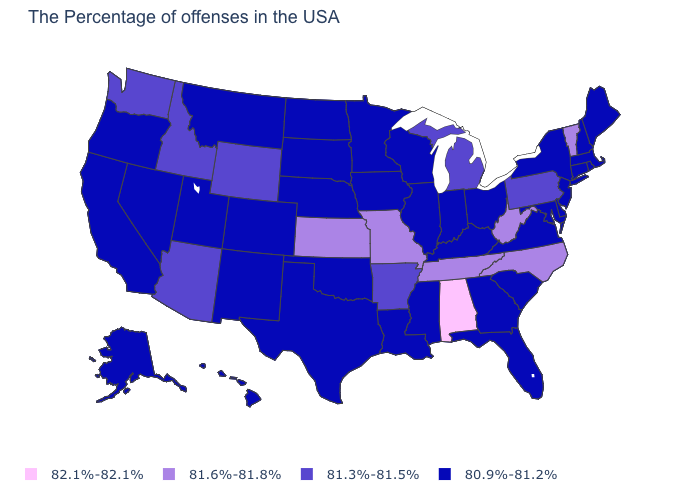What is the value of Utah?
Give a very brief answer. 80.9%-81.2%. Does New Hampshire have the lowest value in the USA?
Be succinct. Yes. What is the value of Wyoming?
Give a very brief answer. 81.3%-81.5%. How many symbols are there in the legend?
Give a very brief answer. 4. What is the value of Georgia?
Concise answer only. 80.9%-81.2%. How many symbols are there in the legend?
Keep it brief. 4. Among the states that border Pennsylvania , does Maryland have the lowest value?
Give a very brief answer. Yes. Name the states that have a value in the range 81.3%-81.5%?
Write a very short answer. Pennsylvania, Michigan, Arkansas, Wyoming, Arizona, Idaho, Washington. Name the states that have a value in the range 80.9%-81.2%?
Short answer required. Maine, Massachusetts, Rhode Island, New Hampshire, Connecticut, New York, New Jersey, Delaware, Maryland, Virginia, South Carolina, Ohio, Florida, Georgia, Kentucky, Indiana, Wisconsin, Illinois, Mississippi, Louisiana, Minnesota, Iowa, Nebraska, Oklahoma, Texas, South Dakota, North Dakota, Colorado, New Mexico, Utah, Montana, Nevada, California, Oregon, Alaska, Hawaii. What is the highest value in states that border Maine?
Give a very brief answer. 80.9%-81.2%. Does Kentucky have the lowest value in the USA?
Short answer required. Yes. Does the first symbol in the legend represent the smallest category?
Short answer required. No. Does the first symbol in the legend represent the smallest category?
Short answer required. No. Which states hav the highest value in the Northeast?
Short answer required. Vermont. 